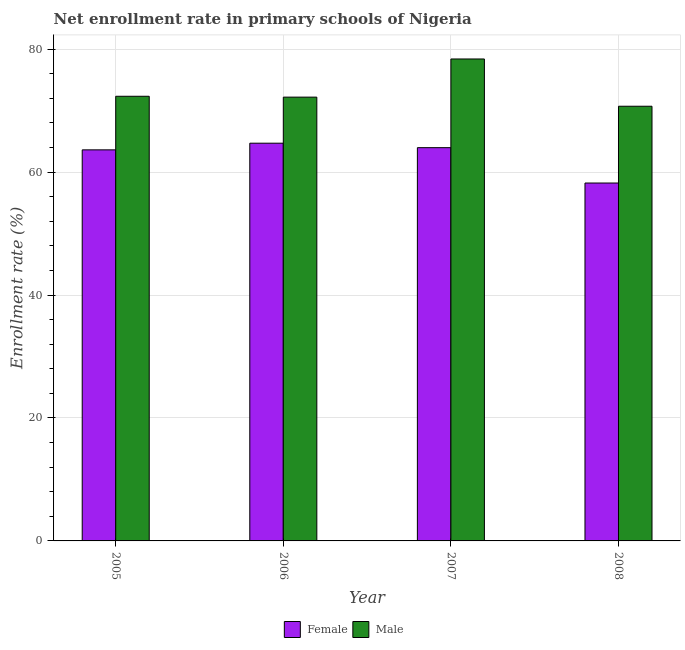How many different coloured bars are there?
Give a very brief answer. 2. How many groups of bars are there?
Offer a very short reply. 4. How many bars are there on the 3rd tick from the right?
Keep it short and to the point. 2. What is the label of the 4th group of bars from the left?
Offer a terse response. 2008. What is the enrollment rate of male students in 2005?
Give a very brief answer. 72.34. Across all years, what is the maximum enrollment rate of male students?
Your answer should be compact. 78.4. Across all years, what is the minimum enrollment rate of male students?
Your response must be concise. 70.72. What is the total enrollment rate of male students in the graph?
Your answer should be compact. 293.65. What is the difference between the enrollment rate of male students in 2006 and that in 2008?
Give a very brief answer. 1.48. What is the difference between the enrollment rate of male students in 2008 and the enrollment rate of female students in 2006?
Provide a short and direct response. -1.48. What is the average enrollment rate of female students per year?
Your answer should be compact. 62.63. What is the ratio of the enrollment rate of male students in 2006 to that in 2008?
Ensure brevity in your answer.  1.02. What is the difference between the highest and the second highest enrollment rate of female students?
Your answer should be compact. 0.73. What is the difference between the highest and the lowest enrollment rate of male students?
Keep it short and to the point. 7.69. Is the sum of the enrollment rate of female students in 2007 and 2008 greater than the maximum enrollment rate of male students across all years?
Your answer should be very brief. Yes. How many bars are there?
Offer a terse response. 8. Are all the bars in the graph horizontal?
Give a very brief answer. No. Does the graph contain any zero values?
Your answer should be very brief. No. Where does the legend appear in the graph?
Offer a very short reply. Bottom center. How are the legend labels stacked?
Your response must be concise. Horizontal. What is the title of the graph?
Provide a succinct answer. Net enrollment rate in primary schools of Nigeria. Does "Enforce a contract" appear as one of the legend labels in the graph?
Provide a short and direct response. No. What is the label or title of the Y-axis?
Provide a short and direct response. Enrollment rate (%). What is the Enrollment rate (%) in Female in 2005?
Offer a terse response. 63.62. What is the Enrollment rate (%) in Male in 2005?
Make the answer very short. 72.34. What is the Enrollment rate (%) of Female in 2006?
Offer a terse response. 64.7. What is the Enrollment rate (%) of Male in 2006?
Offer a very short reply. 72.2. What is the Enrollment rate (%) of Female in 2007?
Make the answer very short. 63.98. What is the Enrollment rate (%) in Male in 2007?
Your answer should be very brief. 78.4. What is the Enrollment rate (%) in Female in 2008?
Your answer should be very brief. 58.22. What is the Enrollment rate (%) of Male in 2008?
Make the answer very short. 70.72. Across all years, what is the maximum Enrollment rate (%) in Female?
Make the answer very short. 64.7. Across all years, what is the maximum Enrollment rate (%) in Male?
Your answer should be compact. 78.4. Across all years, what is the minimum Enrollment rate (%) in Female?
Your answer should be compact. 58.22. Across all years, what is the minimum Enrollment rate (%) in Male?
Provide a short and direct response. 70.72. What is the total Enrollment rate (%) in Female in the graph?
Your answer should be compact. 250.52. What is the total Enrollment rate (%) of Male in the graph?
Make the answer very short. 293.65. What is the difference between the Enrollment rate (%) of Female in 2005 and that in 2006?
Your answer should be compact. -1.08. What is the difference between the Enrollment rate (%) in Male in 2005 and that in 2006?
Keep it short and to the point. 0.14. What is the difference between the Enrollment rate (%) in Female in 2005 and that in 2007?
Make the answer very short. -0.36. What is the difference between the Enrollment rate (%) of Male in 2005 and that in 2007?
Offer a very short reply. -6.07. What is the difference between the Enrollment rate (%) of Female in 2005 and that in 2008?
Provide a short and direct response. 5.4. What is the difference between the Enrollment rate (%) in Male in 2005 and that in 2008?
Your response must be concise. 1.62. What is the difference between the Enrollment rate (%) in Female in 2006 and that in 2007?
Ensure brevity in your answer.  0.73. What is the difference between the Enrollment rate (%) in Male in 2006 and that in 2007?
Make the answer very short. -6.21. What is the difference between the Enrollment rate (%) in Female in 2006 and that in 2008?
Your response must be concise. 6.48. What is the difference between the Enrollment rate (%) of Male in 2006 and that in 2008?
Provide a short and direct response. 1.48. What is the difference between the Enrollment rate (%) of Female in 2007 and that in 2008?
Give a very brief answer. 5.75. What is the difference between the Enrollment rate (%) of Male in 2007 and that in 2008?
Make the answer very short. 7.69. What is the difference between the Enrollment rate (%) of Female in 2005 and the Enrollment rate (%) of Male in 2006?
Your answer should be compact. -8.58. What is the difference between the Enrollment rate (%) of Female in 2005 and the Enrollment rate (%) of Male in 2007?
Make the answer very short. -14.79. What is the difference between the Enrollment rate (%) of Female in 2005 and the Enrollment rate (%) of Male in 2008?
Your response must be concise. -7.1. What is the difference between the Enrollment rate (%) of Female in 2006 and the Enrollment rate (%) of Male in 2007?
Offer a terse response. -13.7. What is the difference between the Enrollment rate (%) of Female in 2006 and the Enrollment rate (%) of Male in 2008?
Make the answer very short. -6.01. What is the difference between the Enrollment rate (%) of Female in 2007 and the Enrollment rate (%) of Male in 2008?
Offer a terse response. -6.74. What is the average Enrollment rate (%) in Female per year?
Keep it short and to the point. 62.63. What is the average Enrollment rate (%) in Male per year?
Your answer should be compact. 73.41. In the year 2005, what is the difference between the Enrollment rate (%) in Female and Enrollment rate (%) in Male?
Provide a succinct answer. -8.72. In the year 2006, what is the difference between the Enrollment rate (%) of Female and Enrollment rate (%) of Male?
Offer a very short reply. -7.49. In the year 2007, what is the difference between the Enrollment rate (%) in Female and Enrollment rate (%) in Male?
Keep it short and to the point. -14.43. In the year 2008, what is the difference between the Enrollment rate (%) of Female and Enrollment rate (%) of Male?
Your response must be concise. -12.49. What is the ratio of the Enrollment rate (%) in Female in 2005 to that in 2006?
Give a very brief answer. 0.98. What is the ratio of the Enrollment rate (%) of Male in 2005 to that in 2006?
Your response must be concise. 1. What is the ratio of the Enrollment rate (%) in Male in 2005 to that in 2007?
Offer a very short reply. 0.92. What is the ratio of the Enrollment rate (%) in Female in 2005 to that in 2008?
Your answer should be compact. 1.09. What is the ratio of the Enrollment rate (%) in Male in 2005 to that in 2008?
Ensure brevity in your answer.  1.02. What is the ratio of the Enrollment rate (%) of Female in 2006 to that in 2007?
Your answer should be compact. 1.01. What is the ratio of the Enrollment rate (%) in Male in 2006 to that in 2007?
Give a very brief answer. 0.92. What is the ratio of the Enrollment rate (%) in Female in 2006 to that in 2008?
Give a very brief answer. 1.11. What is the ratio of the Enrollment rate (%) in Male in 2006 to that in 2008?
Keep it short and to the point. 1.02. What is the ratio of the Enrollment rate (%) of Female in 2007 to that in 2008?
Provide a succinct answer. 1.1. What is the ratio of the Enrollment rate (%) in Male in 2007 to that in 2008?
Give a very brief answer. 1.11. What is the difference between the highest and the second highest Enrollment rate (%) in Female?
Offer a very short reply. 0.73. What is the difference between the highest and the second highest Enrollment rate (%) in Male?
Provide a succinct answer. 6.07. What is the difference between the highest and the lowest Enrollment rate (%) in Female?
Your answer should be very brief. 6.48. What is the difference between the highest and the lowest Enrollment rate (%) of Male?
Offer a very short reply. 7.69. 